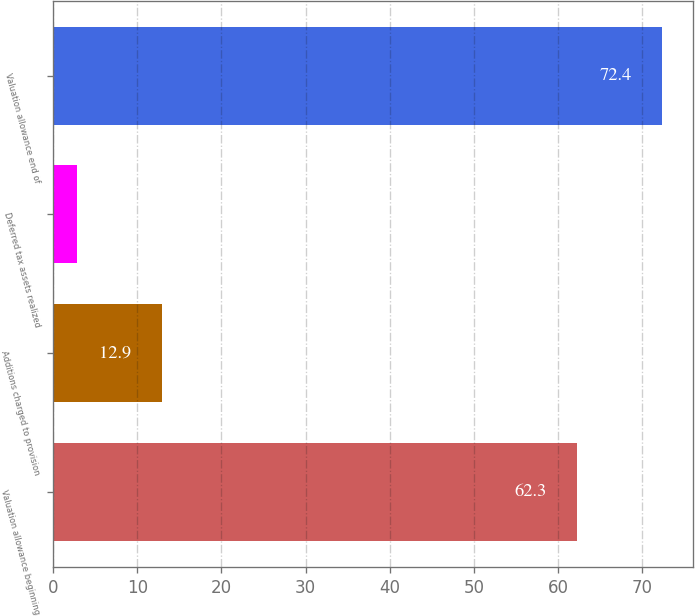Convert chart. <chart><loc_0><loc_0><loc_500><loc_500><bar_chart><fcel>Valuation allowance beginning<fcel>Additions charged to provision<fcel>Deferred tax assets realized<fcel>Valuation allowance end of<nl><fcel>62.3<fcel>12.9<fcel>2.8<fcel>72.4<nl></chart> 